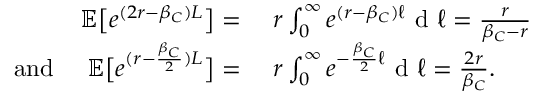<formula> <loc_0><loc_0><loc_500><loc_500>\begin{array} { r l } { { \mathbb { E } } \left [ e ^ { ( 2 r - \beta _ { C } ) L } \right ] = } & { \ r \int _ { 0 } ^ { \infty } e ^ { ( r - \beta _ { C } ) \ell } d \ell = \frac { r } { \beta _ { C } - r } } \\ { \quad a n d \quad \mathbb { E } \left [ e ^ { ( r - \frac { \beta _ { C } } { 2 } ) L } \right ] = } & { \ r \int _ { 0 } ^ { \infty } e ^ { - \frac { \beta _ { C } } { 2 } \ell } d \ell = \frac { 2 r } { \beta _ { C } } . } \end{array}</formula> 